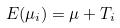<formula> <loc_0><loc_0><loc_500><loc_500>E ( \mu _ { i } ) = \mu + T _ { i }</formula> 